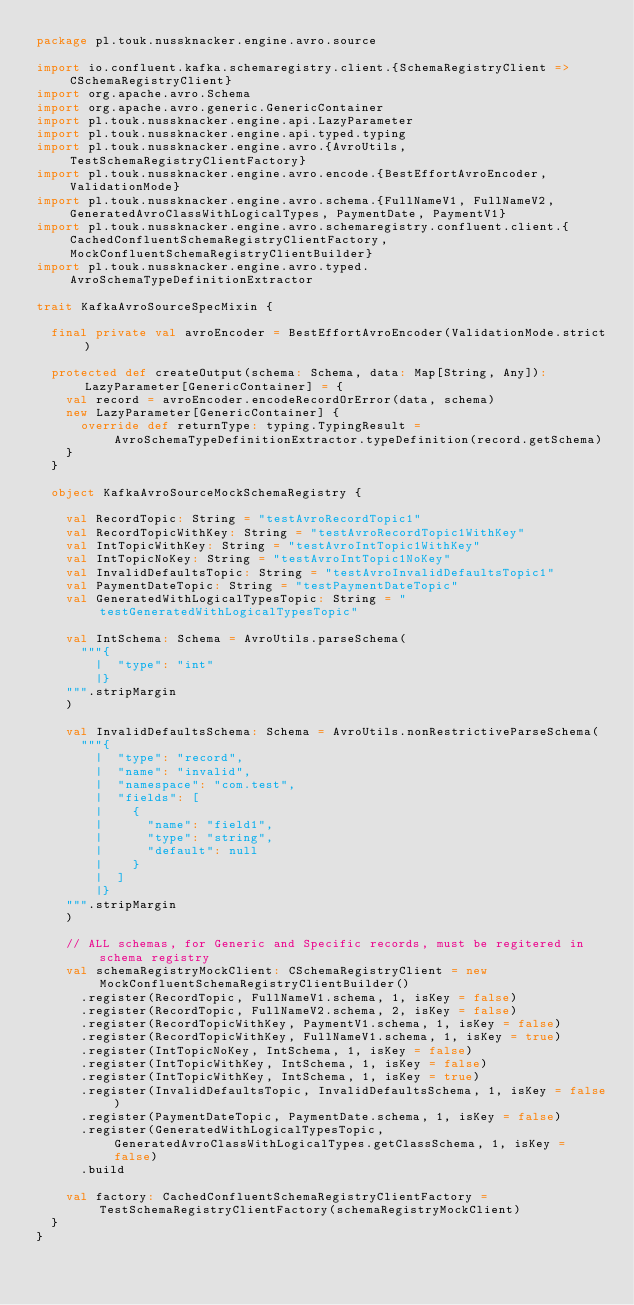Convert code to text. <code><loc_0><loc_0><loc_500><loc_500><_Scala_>package pl.touk.nussknacker.engine.avro.source

import io.confluent.kafka.schemaregistry.client.{SchemaRegistryClient => CSchemaRegistryClient}
import org.apache.avro.Schema
import org.apache.avro.generic.GenericContainer
import pl.touk.nussknacker.engine.api.LazyParameter
import pl.touk.nussknacker.engine.api.typed.typing
import pl.touk.nussknacker.engine.avro.{AvroUtils, TestSchemaRegistryClientFactory}
import pl.touk.nussknacker.engine.avro.encode.{BestEffortAvroEncoder, ValidationMode}
import pl.touk.nussknacker.engine.avro.schema.{FullNameV1, FullNameV2, GeneratedAvroClassWithLogicalTypes, PaymentDate, PaymentV1}
import pl.touk.nussknacker.engine.avro.schemaregistry.confluent.client.{CachedConfluentSchemaRegistryClientFactory, MockConfluentSchemaRegistryClientBuilder}
import pl.touk.nussknacker.engine.avro.typed.AvroSchemaTypeDefinitionExtractor

trait KafkaAvroSourceSpecMixin {

  final private val avroEncoder = BestEffortAvroEncoder(ValidationMode.strict)

  protected def createOutput(schema: Schema, data: Map[String, Any]): LazyParameter[GenericContainer] = {
    val record = avroEncoder.encodeRecordOrError(data, schema)
    new LazyParameter[GenericContainer] {
      override def returnType: typing.TypingResult = AvroSchemaTypeDefinitionExtractor.typeDefinition(record.getSchema)
    }
  }

  object KafkaAvroSourceMockSchemaRegistry {

    val RecordTopic: String = "testAvroRecordTopic1"
    val RecordTopicWithKey: String = "testAvroRecordTopic1WithKey"
    val IntTopicWithKey: String = "testAvroIntTopic1WithKey"
    val IntTopicNoKey: String = "testAvroIntTopic1NoKey"
    val InvalidDefaultsTopic: String = "testAvroInvalidDefaultsTopic1"
    val PaymentDateTopic: String = "testPaymentDateTopic"
    val GeneratedWithLogicalTypesTopic: String = "testGeneratedWithLogicalTypesTopic"

    val IntSchema: Schema = AvroUtils.parseSchema(
      """{
        |  "type": "int"
        |}
    """.stripMargin
    )

    val InvalidDefaultsSchema: Schema = AvroUtils.nonRestrictiveParseSchema(
      """{
        |  "type": "record",
        |  "name": "invalid",
        |  "namespace": "com.test",
        |  "fields": [
        |    {
        |      "name": "field1",
        |      "type": "string",
        |      "default": null
        |    }
        |  ]
        |}
    """.stripMargin
    )

    // ALL schemas, for Generic and Specific records, must be regitered in schema registry
    val schemaRegistryMockClient: CSchemaRegistryClient = new MockConfluentSchemaRegistryClientBuilder()
      .register(RecordTopic, FullNameV1.schema, 1, isKey = false)
      .register(RecordTopic, FullNameV2.schema, 2, isKey = false)
      .register(RecordTopicWithKey, PaymentV1.schema, 1, isKey = false)
      .register(RecordTopicWithKey, FullNameV1.schema, 1, isKey = true)
      .register(IntTopicNoKey, IntSchema, 1, isKey = false)
      .register(IntTopicWithKey, IntSchema, 1, isKey = false)
      .register(IntTopicWithKey, IntSchema, 1, isKey = true)
      .register(InvalidDefaultsTopic, InvalidDefaultsSchema, 1, isKey = false)
      .register(PaymentDateTopic, PaymentDate.schema, 1, isKey = false)
      .register(GeneratedWithLogicalTypesTopic, GeneratedAvroClassWithLogicalTypes.getClassSchema, 1, isKey = false)
      .build

    val factory: CachedConfluentSchemaRegistryClientFactory = TestSchemaRegistryClientFactory(schemaRegistryMockClient)
  }
}
</code> 